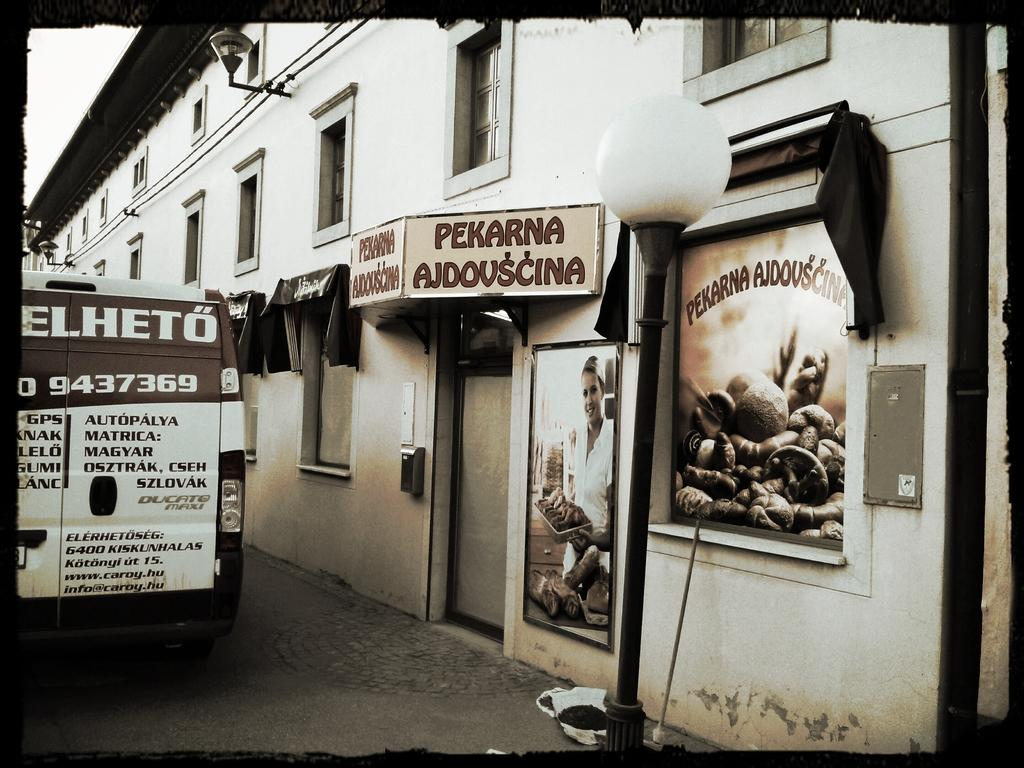<image>
Share a concise interpretation of the image provided. the word Pekarna is on the street shop 